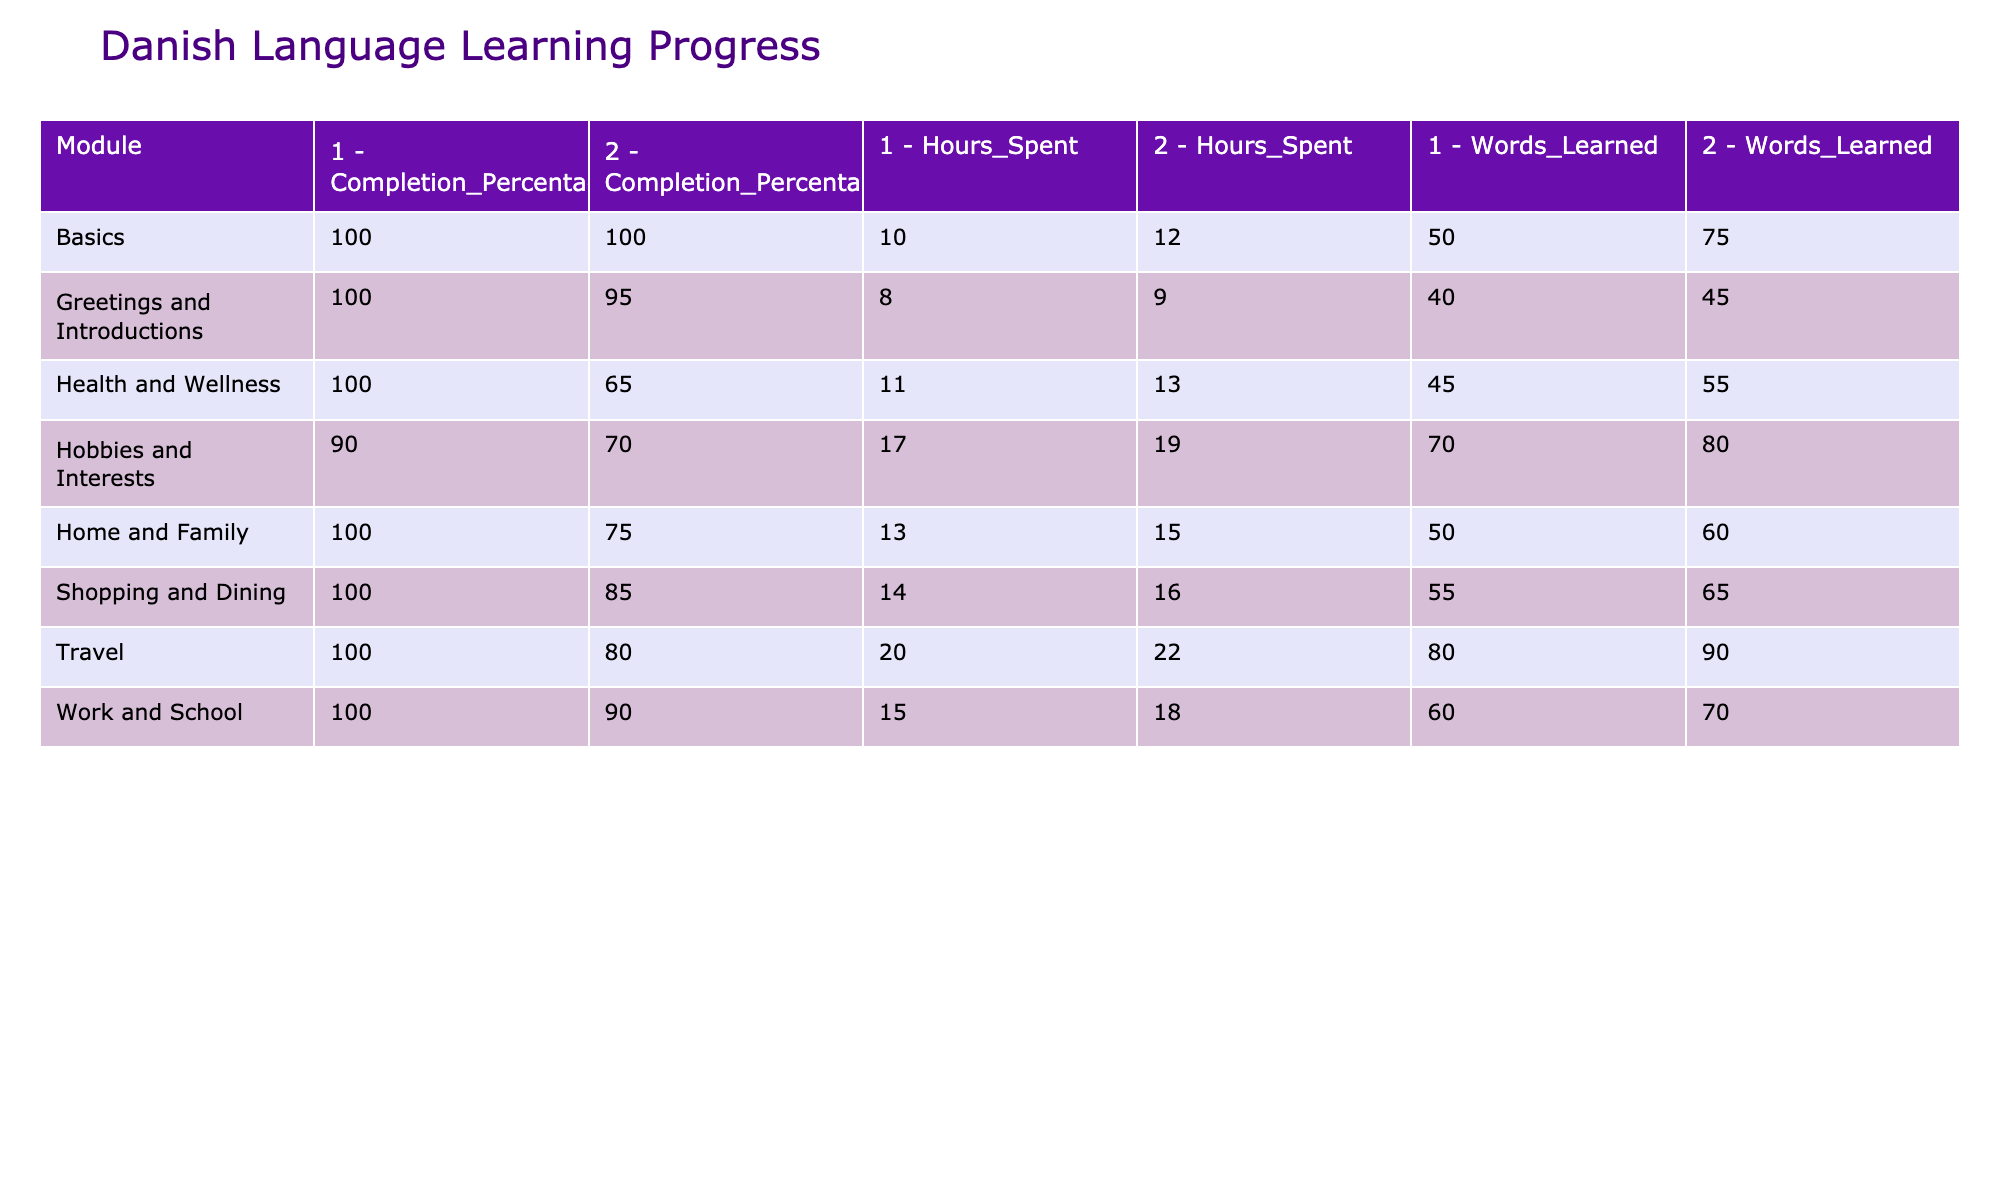What is the highest number of words learned in a single module? From the table, the highest value for 'Words Learned' is found under the 'Travel' module, Level 2, which has 90 words learned.
Answer: 90 Which module has the lowest completion percentage? When evaluating the 'Completion Percentage' column, 'Health and Wellness' Level 2 has the lowest percentage at 65%.
Answer: 65% Calculate the average hours spent on the 'Shopping and Dining' module. The hours spent in 'Shopping and Dining' are 14 for Level 1 and 16 for Level 2. The sum is 14 + 16 = 30. The average is 30/2 = 15.
Answer: 15 Did John learn more words in the 'Basics' module than in the 'Hobbies and Interests' module? In the 'Basics' module, a total of 50 + 75 = 125 words were learned. In 'Hobbies and Interests,' the total is 70 + 80 = 150 words. Thus, he learned fewer words in 'Basics.'
Answer: No What is the average grammar score across all modules? To find the average, sum all grammar scores: 85 + 82 + 88 + 86 + 79 + 81 + 83 + 80 + 77 + 79 + 84 + 82 + 78 + 80 + 86 + 84 = 1265. There are 16 levels, so the average is 1265/16 = approximately 79.0625.
Answer: 79.06 In which module did John spend the most hours in total? When adding the hours spent across the levels, 'Travel' shows the highest total of 20 + 22 = 42 hours.
Answer: Travel How does John’s listening score compare between 'Work and School' and 'Hobbies and Interests' at Level 2? The listening score for 'Work and School' Level 2 is 78, while for 'Hobbies and Interests' Level 2, it is 78 as well. Therefore, they are equal.
Answer: Equal What is the difference in the number of words learned between Level 1 and Level 2 for the 'Home and Family' module? In 'Home and Family,' Level 1 has 50 words learned, and Level 2 has 60. The difference is 60 - 50 = 10.
Answer: 10 